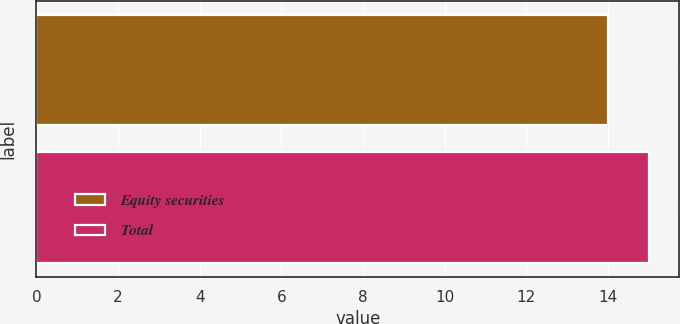Convert chart to OTSL. <chart><loc_0><loc_0><loc_500><loc_500><bar_chart><fcel>Equity securities<fcel>Total<nl><fcel>14<fcel>15<nl></chart> 